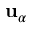<formula> <loc_0><loc_0><loc_500><loc_500>u _ { \alpha }</formula> 